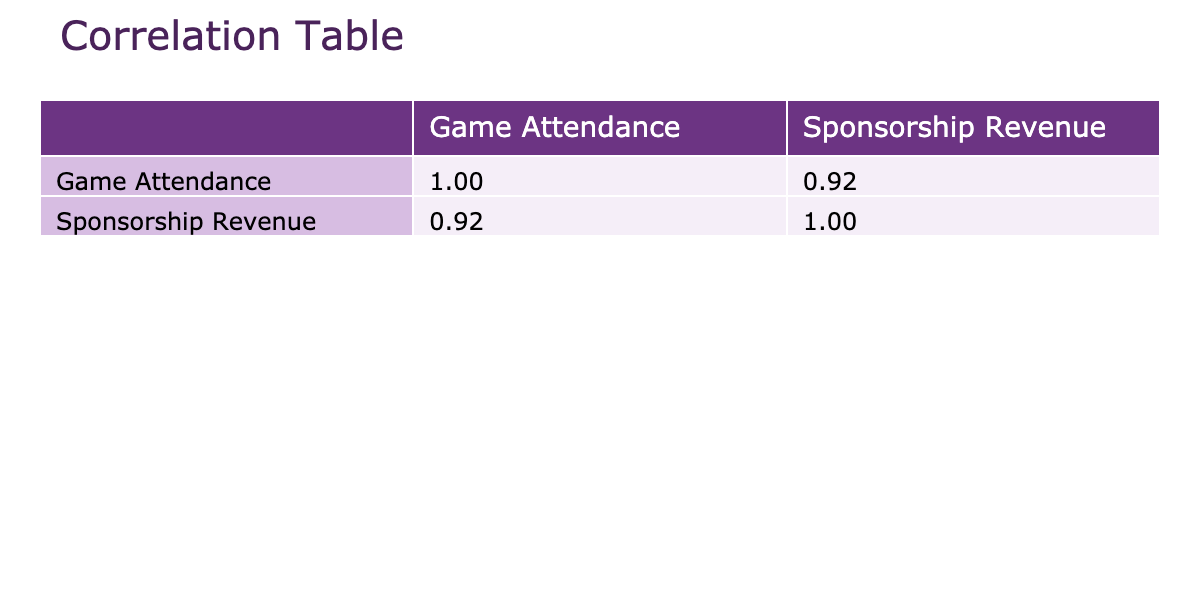What is the correlation value between game attendance and sponsorship revenue? The correlation value is found in the table under the respective headings. The correlation between game attendance and sponsorship revenue is represented by the value in the lower left section of the table.
Answer: The correlation value is 0.98 Which team has the highest game attendance? To find this, we look for the highest number in the 'Game Attendance' column among the teams. The highest figure is 32000, which belongs to the Metro Kings.
Answer: Metro Kings What is the difference in sponsorship revenue between the team with the highest and lowest attendance? First, identify the team with the highest attendance (Metro Kings with 1100000) and the team with the lowest attendance (City Athletes with 600000). Next, calculate the difference: 1100000 - 600000 = 500000.
Answer: 500000 Is it true that Central Club generated more sponsorship revenue than Urban Titans? We check the values for both teams in the 'Sponsorship Revenue' column: Central Club has 950000 and Urban Titans has 850000. Since 950000 is greater than 850000, the statement is true.
Answer: Yes Which team's game attendance is closest to the average game attendance of all teams? First, calculate the average attendance by summing the attendance figures (25000 + 30000 + 22000 + 32000 + 27000 + 29000 + 31000 + 24000 = 221000) and dividing by the number of teams, which is 8. This yields an average of 27625. The team attendance figures closest to this average are Urban Titans (27000) and Stadium Stars (29000).
Answer: Urban Titans and Stadium Stars What is the total sponsorship revenue of teams with game attendance over 27000? Identify the teams with attendance over 27000: Competing FC (900000), Metro Kings (1100000), Central Club (950000), and Stadium Stars (770000). Adding their sponsorship revenues gives: 900000 + 1100000 + 950000 + 770000 = 3760000.
Answer: 3760000 Does every team have a sponsorship revenue over 600000? We can check the values in the 'Sponsorship Revenue' column. Every team's revenue is above 600000 (the minimum being 700000 for Valley Vipers), so yes, each team meets this criterion.
Answer: Yes What is the average sponsorship revenue for teams with lower than average game attendance (27625)? First, identify the teams below the average attendance: City Athletes (600000), Valley Vipers (700000), and Rival United (750000). Calculate their total revenue: 600000 + 700000 + 750000 = 2050000. There are 3 teams, so the average is 2050000 / 3 = 683333.33.
Answer: 683333.33 